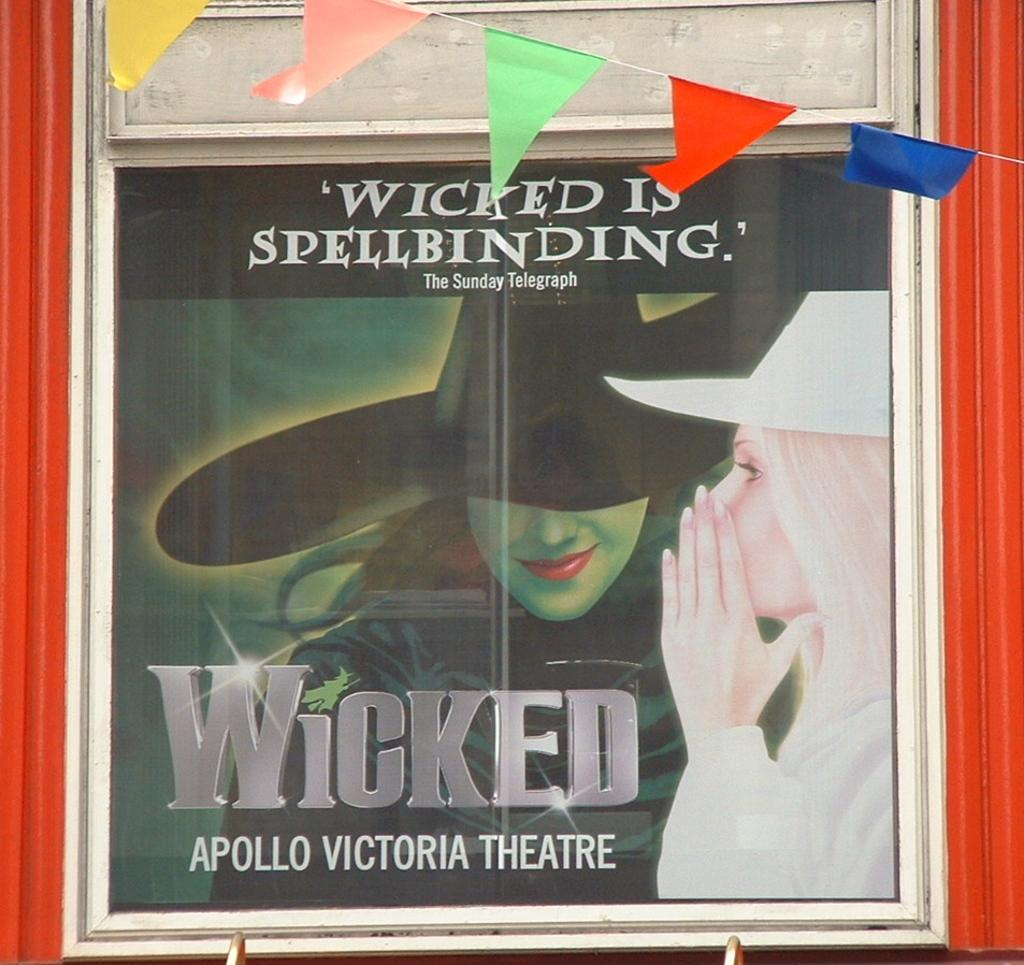<image>
Provide a brief description of the given image. an ad for the play Wicked at the Apollo Victoria Theater 